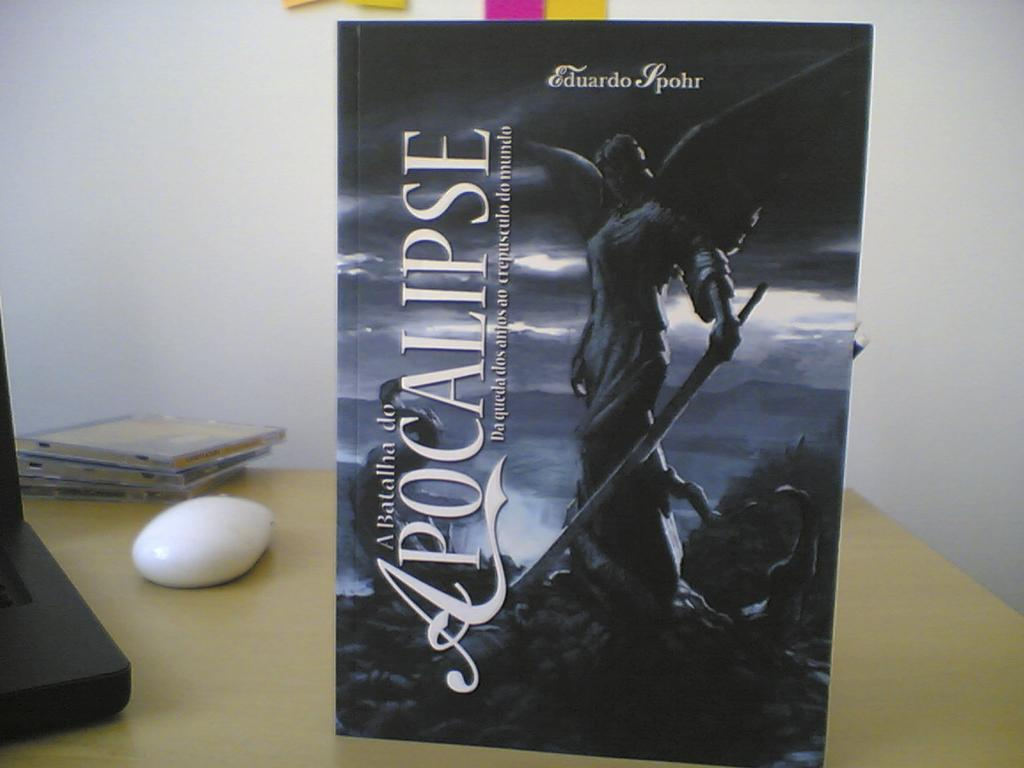<image>
Provide a brief description of the given image. A picture of a winged angel is on a desk and it is titled A Batallina de Apocalipse. 